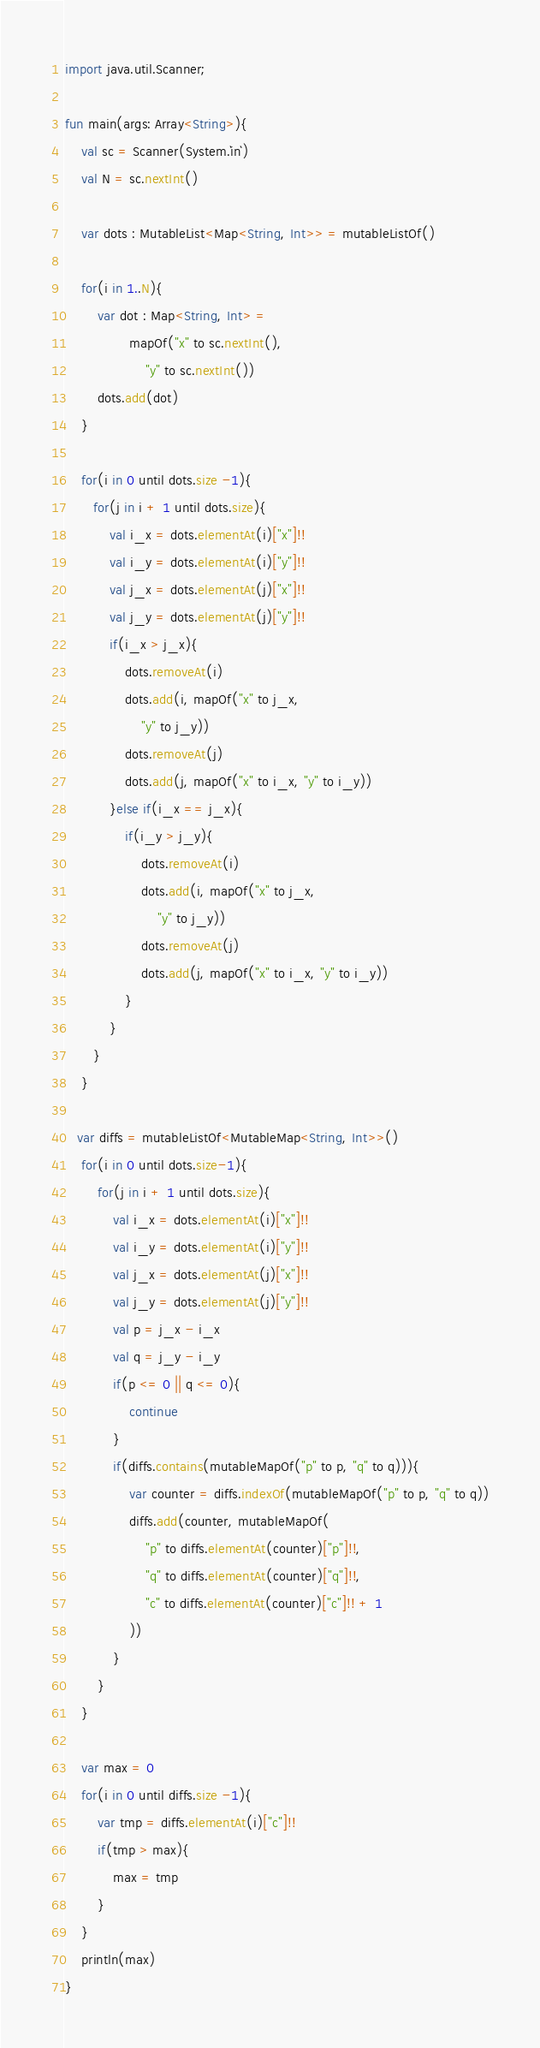<code> <loc_0><loc_0><loc_500><loc_500><_Kotlin_>import java.util.Scanner;

fun main(args: Array<String>){
    val sc = Scanner(System.`in`)
    val N = sc.nextInt()

    var dots : MutableList<Map<String, Int>> = mutableListOf()

    for(i in 1..N){
        var dot : Map<String, Int> =
                mapOf("x" to sc.nextInt(),
                    "y" to sc.nextInt())
        dots.add(dot)
    }

    for(i in 0 until dots.size -1){
       for(j in i + 1 until dots.size){
           val i_x = dots.elementAt(i)["x"]!!
           val i_y = dots.elementAt(i)["y"]!!
           val j_x = dots.elementAt(j)["x"]!!
           val j_y = dots.elementAt(j)["y"]!!
           if(i_x > j_x){
               dots.removeAt(i)
               dots.add(i, mapOf("x" to j_x,
                   "y" to j_y))
               dots.removeAt(j)
               dots.add(j, mapOf("x" to i_x, "y" to i_y))
           }else if(i_x == j_x){
               if(i_y > j_y){
                   dots.removeAt(i)
                   dots.add(i, mapOf("x" to j_x,
                       "y" to j_y))
                   dots.removeAt(j)
                   dots.add(j, mapOf("x" to i_x, "y" to i_y))
               }
           }
       }
    }

   var diffs = mutableListOf<MutableMap<String, Int>>()
    for(i in 0 until dots.size-1){
        for(j in i + 1 until dots.size){
            val i_x = dots.elementAt(i)["x"]!!
            val i_y = dots.elementAt(i)["y"]!!
            val j_x = dots.elementAt(j)["x"]!!
            val j_y = dots.elementAt(j)["y"]!!
            val p = j_x - i_x
            val q = j_y - i_y
            if(p <= 0 || q <= 0){
                continue
            }
            if(diffs.contains(mutableMapOf("p" to p, "q" to q))){
                var counter = diffs.indexOf(mutableMapOf("p" to p, "q" to q))
                diffs.add(counter, mutableMapOf(
                    "p" to diffs.elementAt(counter)["p"]!!,
                    "q" to diffs.elementAt(counter)["q"]!!,
                    "c" to diffs.elementAt(counter)["c"]!! + 1 
                ))
            }
        }
    }
    
    var max = 0
    for(i in 0 until diffs.size -1){
        var tmp = diffs.elementAt(i)["c"]!!
        if(tmp > max){
            max = tmp
        }
    }
    println(max)
}</code> 